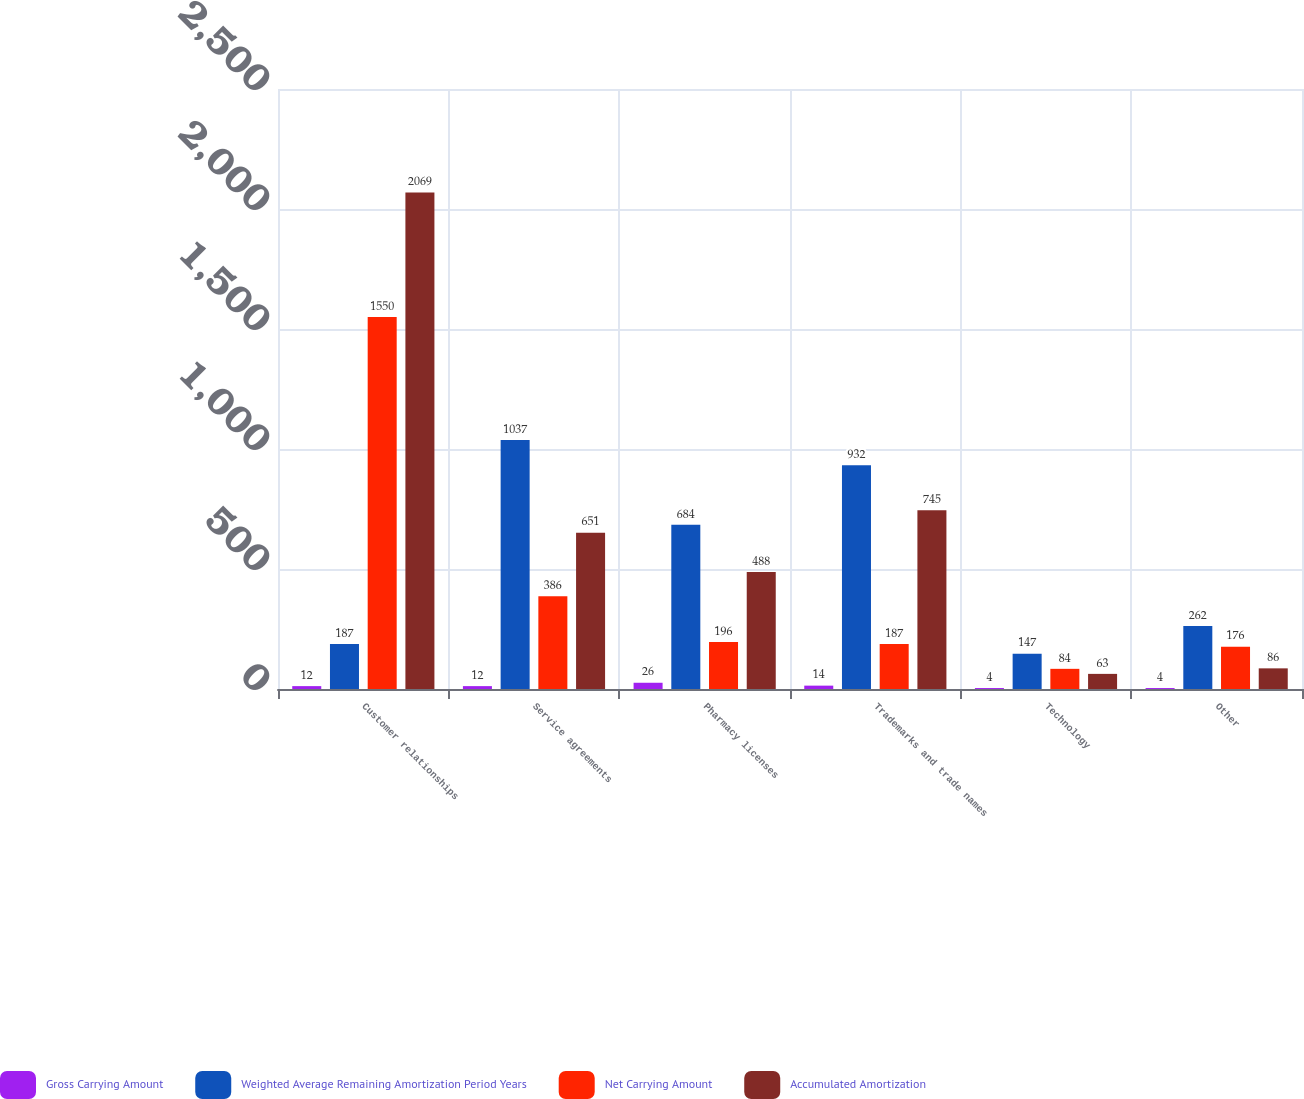<chart> <loc_0><loc_0><loc_500><loc_500><stacked_bar_chart><ecel><fcel>Customer relationships<fcel>Service agreements<fcel>Pharmacy licenses<fcel>Trademarks and trade names<fcel>Technology<fcel>Other<nl><fcel>Gross Carrying Amount<fcel>12<fcel>12<fcel>26<fcel>14<fcel>4<fcel>4<nl><fcel>Weighted Average Remaining Amortization Period Years<fcel>187<fcel>1037<fcel>684<fcel>932<fcel>147<fcel>262<nl><fcel>Net Carrying Amount<fcel>1550<fcel>386<fcel>196<fcel>187<fcel>84<fcel>176<nl><fcel>Accumulated Amortization<fcel>2069<fcel>651<fcel>488<fcel>745<fcel>63<fcel>86<nl></chart> 